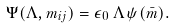<formula> <loc_0><loc_0><loc_500><loc_500>\Psi ( \Lambda , m _ { i j } ) = \epsilon _ { 0 } \, \Lambda \, \psi ( \bar { m } ) .</formula> 